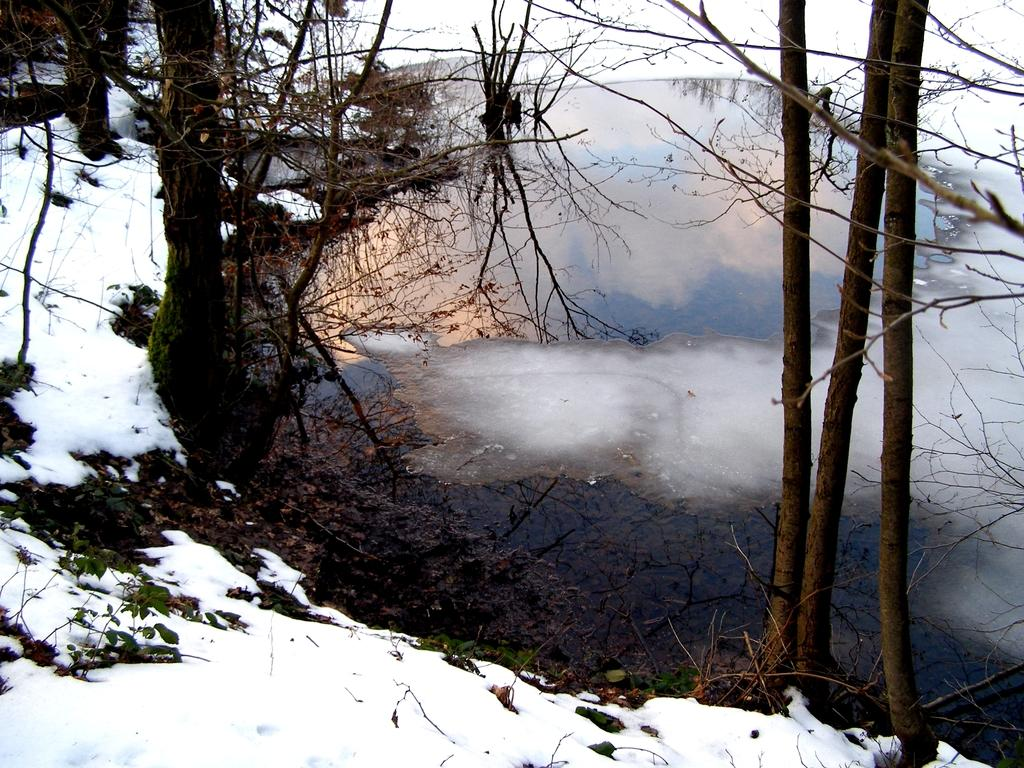What is the general appearance of the location in the image? The image shows a place covered with snow. What type of natural elements can be seen in the image? There are trees in the image. What holiday is being celebrated in the image? There is no indication of a holiday being celebrated in the image. What process is being used to create the snow in the image? The image is a photograph, and the snow is a natural occurrence, not a process being depicted. 